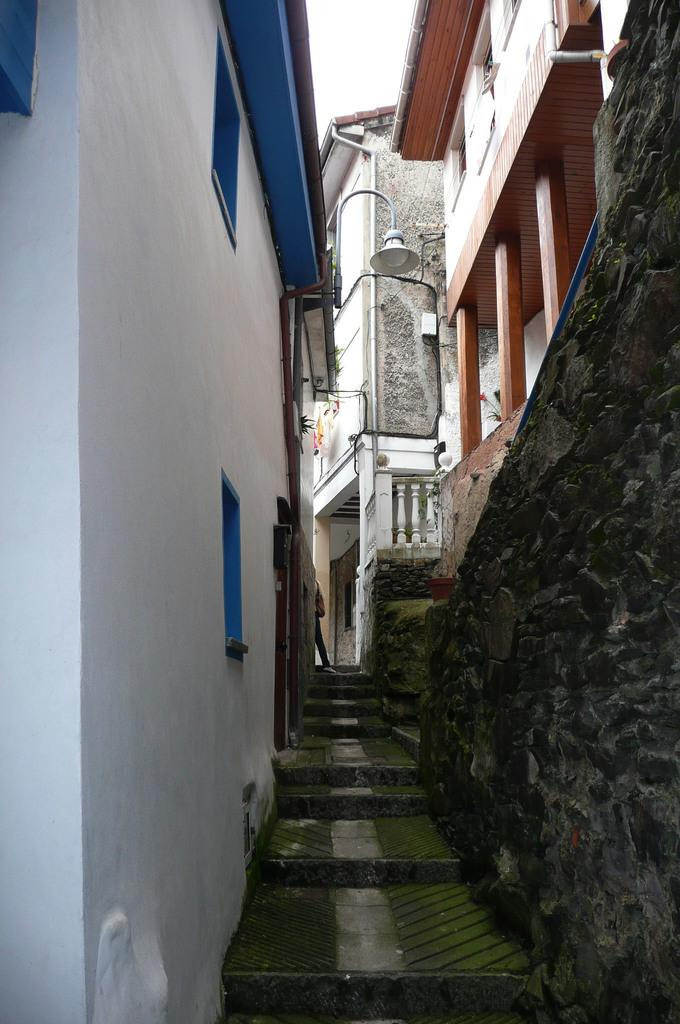What is located in the center of the image? There are steps in the center of the image. What can be seen on the right side of the image? There are buildings on the right side of the image. What can be seen on the left side of the image? There are buildings on the left side of the image. What is visible in the background of the image? The sky is visible in the background of the image. What type of pie is being served on the floor in the image? There is no pie or floor present in the image; it features steps and buildings with the sky visible in the background. 